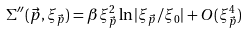<formula> <loc_0><loc_0><loc_500><loc_500>\Sigma ^ { \prime \prime } ( { \vec { p } } , \xi _ { \vec { p } } ) = \beta \xi _ { \vec { p } } ^ { 2 } \ln | \xi _ { \vec { p } } / \xi _ { 0 } | + O ( \xi _ { \vec { p } } ^ { 4 } )</formula> 